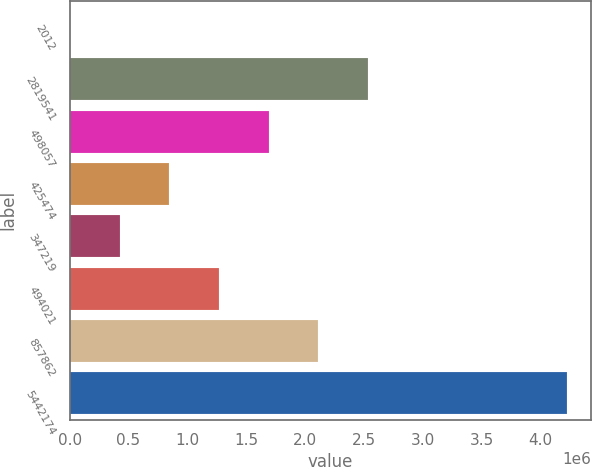<chart> <loc_0><loc_0><loc_500><loc_500><bar_chart><fcel>2012<fcel>2819541<fcel>498057<fcel>425474<fcel>347219<fcel>494021<fcel>857862<fcel>5442174<nl><fcel>2012<fcel>2.53488e+06<fcel>1.69059e+06<fcel>846302<fcel>424157<fcel>1.26845e+06<fcel>2.11274e+06<fcel>4.22346e+06<nl></chart> 